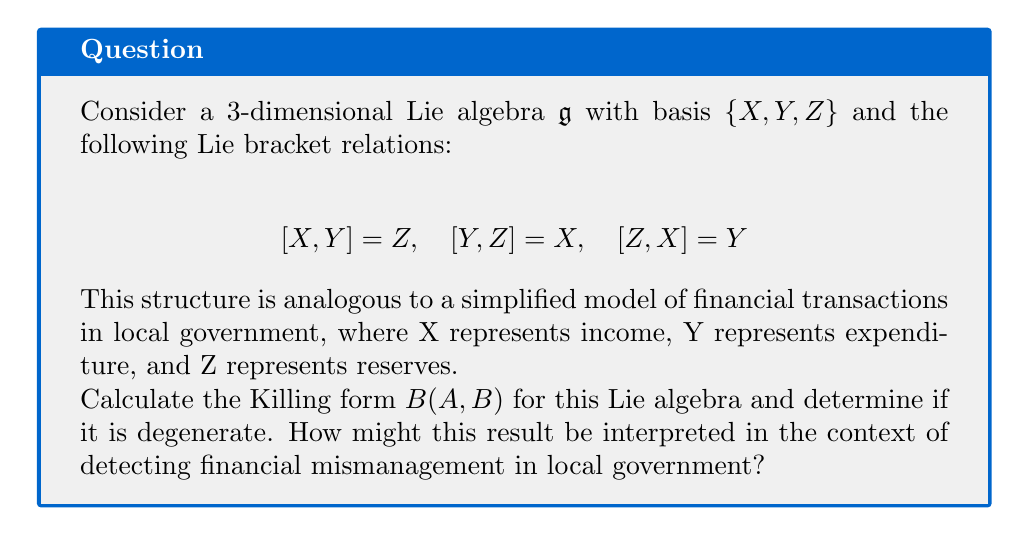Help me with this question. Let's approach this step-by-step:

1) The Killing form is defined as $B(A,B) = \text{tr}(\text{ad}_A \circ \text{ad}_B)$, where $\text{ad}_A$ is the adjoint representation of A.

2) First, we need to find the matrix representations of $\text{ad}_X$, $\text{ad}_Y$, and $\text{ad}_Z$:

   $\text{ad}_X = \begin{pmatrix} 0 & 0 & -1 \\ 0 & 0 & 1 \\ 1 & -1 & 0 \end{pmatrix}$

   $\text{ad}_Y = \begin{pmatrix} 0 & 0 & 1 \\ 0 & 0 & -1 \\ -1 & 1 & 0 \end{pmatrix}$

   $\text{ad}_Z = \begin{pmatrix} 0 & -1 & 0 \\ 1 & 0 & 0 \\ 0 & 0 & 0 \end{pmatrix}$

3) Now, we calculate $B(X,X)$, $B(Y,Y)$, and $B(Z,Z)$:

   $B(X,X) = \text{tr}(\text{ad}_X \circ \text{ad}_X) = -2$
   $B(Y,Y) = \text{tr}(\text{ad}_Y \circ \text{ad}_Y) = -2$
   $B(Z,Z) = \text{tr}(\text{ad}_Z \circ \text{ad}_Z) = -2$

4) We also calculate the off-diagonal elements:

   $B(X,Y) = B(Y,X) = \text{tr}(\text{ad}_X \circ \text{ad}_Y) = 0$
   $B(X,Z) = B(Z,X) = \text{tr}(\text{ad}_X \circ \text{ad}_Z) = 0$
   $B(Y,Z) = B(Z,Y) = \text{tr}(\text{ad}_Y \circ \text{ad}_Z) = 0$

5) Therefore, the Killing form matrix is:

   $B = \begin{pmatrix} -2 & 0 & 0 \\ 0 & -2 & 0 \\ 0 & 0 & -2 \end{pmatrix}$

6) The determinant of this matrix is $-8 \neq 0$, so the Killing form is non-degenerate.

Interpretation: In the context of local government finances, the non-degeneracy of the Killing form suggests that the financial system is well-structured and balanced. Each component (income, expenditure, reserves) has a distinct and significant role. If the Killing form were degenerate, it might indicate redundancy or lack of independence in financial operations, which could potentially mask mismanagement. The equal diagonal entries (-2) suggest that each component has equal "weight" or importance in the overall financial structure, promoting a balanced approach to financial management.
Answer: The Killing form is $B = \text{diag}(-2,-2,-2)$, which is non-degenerate. This suggests a well-structured, balanced financial system where mismanagement would be harder to conceal. 